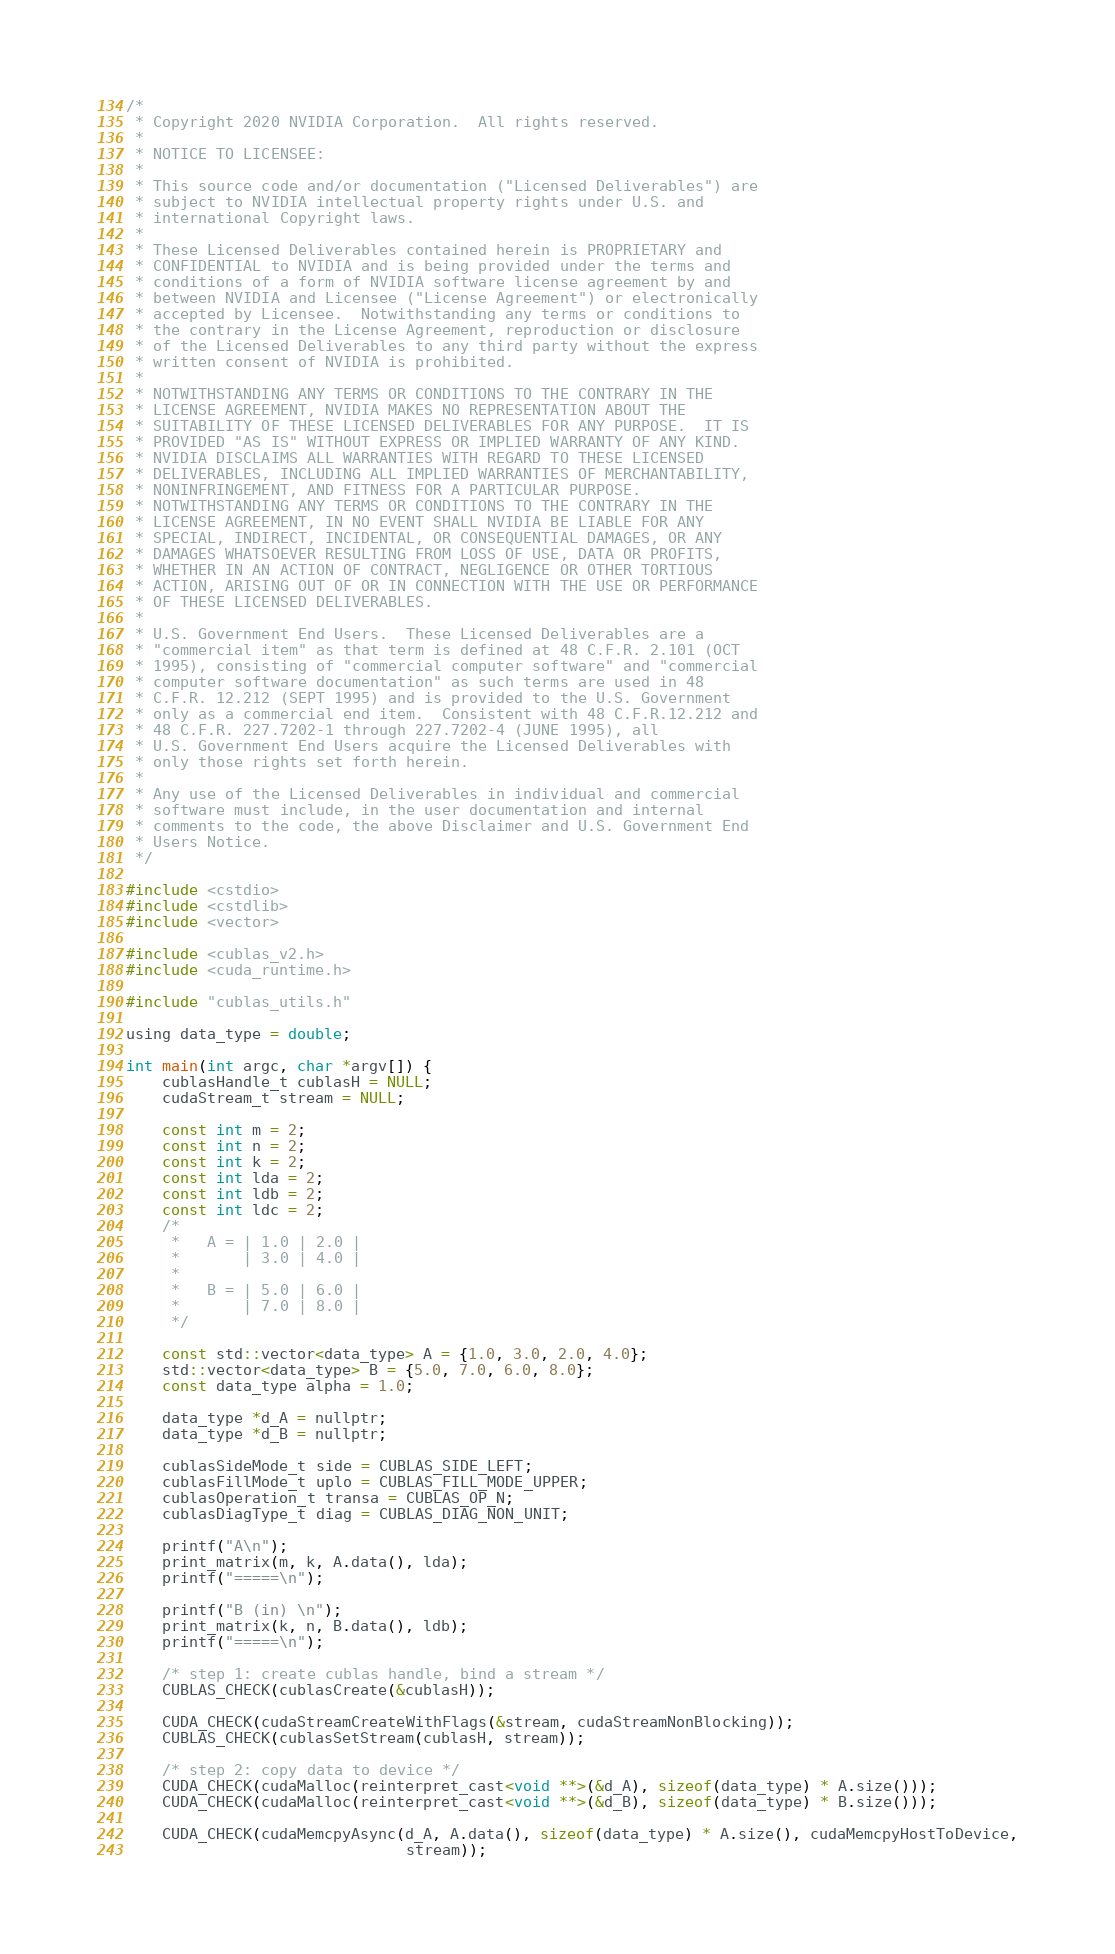<code> <loc_0><loc_0><loc_500><loc_500><_Cuda_>/*
 * Copyright 2020 NVIDIA Corporation.  All rights reserved.
 *
 * NOTICE TO LICENSEE:
 *
 * This source code and/or documentation ("Licensed Deliverables") are
 * subject to NVIDIA intellectual property rights under U.S. and
 * international Copyright laws.
 *
 * These Licensed Deliverables contained herein is PROPRIETARY and
 * CONFIDENTIAL to NVIDIA and is being provided under the terms and
 * conditions of a form of NVIDIA software license agreement by and
 * between NVIDIA and Licensee ("License Agreement") or electronically
 * accepted by Licensee.  Notwithstanding any terms or conditions to
 * the contrary in the License Agreement, reproduction or disclosure
 * of the Licensed Deliverables to any third party without the express
 * written consent of NVIDIA is prohibited.
 *
 * NOTWITHSTANDING ANY TERMS OR CONDITIONS TO THE CONTRARY IN THE
 * LICENSE AGREEMENT, NVIDIA MAKES NO REPRESENTATION ABOUT THE
 * SUITABILITY OF THESE LICENSED DELIVERABLES FOR ANY PURPOSE.  IT IS
 * PROVIDED "AS IS" WITHOUT EXPRESS OR IMPLIED WARRANTY OF ANY KIND.
 * NVIDIA DISCLAIMS ALL WARRANTIES WITH REGARD TO THESE LICENSED
 * DELIVERABLES, INCLUDING ALL IMPLIED WARRANTIES OF MERCHANTABILITY,
 * NONINFRINGEMENT, AND FITNESS FOR A PARTICULAR PURPOSE.
 * NOTWITHSTANDING ANY TERMS OR CONDITIONS TO THE CONTRARY IN THE
 * LICENSE AGREEMENT, IN NO EVENT SHALL NVIDIA BE LIABLE FOR ANY
 * SPECIAL, INDIRECT, INCIDENTAL, OR CONSEQUENTIAL DAMAGES, OR ANY
 * DAMAGES WHATSOEVER RESULTING FROM LOSS OF USE, DATA OR PROFITS,
 * WHETHER IN AN ACTION OF CONTRACT, NEGLIGENCE OR OTHER TORTIOUS
 * ACTION, ARISING OUT OF OR IN CONNECTION WITH THE USE OR PERFORMANCE
 * OF THESE LICENSED DELIVERABLES.
 *
 * U.S. Government End Users.  These Licensed Deliverables are a
 * "commercial item" as that term is defined at 48 C.F.R. 2.101 (OCT
 * 1995), consisting of "commercial computer software" and "commercial
 * computer software documentation" as such terms are used in 48
 * C.F.R. 12.212 (SEPT 1995) and is provided to the U.S. Government
 * only as a commercial end item.  Consistent with 48 C.F.R.12.212 and
 * 48 C.F.R. 227.7202-1 through 227.7202-4 (JUNE 1995), all
 * U.S. Government End Users acquire the Licensed Deliverables with
 * only those rights set forth herein.
 *
 * Any use of the Licensed Deliverables in individual and commercial
 * software must include, in the user documentation and internal
 * comments to the code, the above Disclaimer and U.S. Government End
 * Users Notice.
 */

#include <cstdio>
#include <cstdlib>
#include <vector>

#include <cublas_v2.h>
#include <cuda_runtime.h>

#include "cublas_utils.h"

using data_type = double;

int main(int argc, char *argv[]) {
    cublasHandle_t cublasH = NULL;
    cudaStream_t stream = NULL;

    const int m = 2;
    const int n = 2;
    const int k = 2;
    const int lda = 2;
    const int ldb = 2;
    const int ldc = 2;
    /*
     *   A = | 1.0 | 2.0 |
     *       | 3.0 | 4.0 |
     *
     *   B = | 5.0 | 6.0 |
     *       | 7.0 | 8.0 |
     */

    const std::vector<data_type> A = {1.0, 3.0, 2.0, 4.0};
    std::vector<data_type> B = {5.0, 7.0, 6.0, 8.0};
    const data_type alpha = 1.0;

    data_type *d_A = nullptr;
    data_type *d_B = nullptr;

    cublasSideMode_t side = CUBLAS_SIDE_LEFT;
    cublasFillMode_t uplo = CUBLAS_FILL_MODE_UPPER;
    cublasOperation_t transa = CUBLAS_OP_N;
    cublasDiagType_t diag = CUBLAS_DIAG_NON_UNIT;

    printf("A\n");
    print_matrix(m, k, A.data(), lda);
    printf("=====\n");

    printf("B (in) \n");
    print_matrix(k, n, B.data(), ldb);
    printf("=====\n");

    /* step 1: create cublas handle, bind a stream */
    CUBLAS_CHECK(cublasCreate(&cublasH));

    CUDA_CHECK(cudaStreamCreateWithFlags(&stream, cudaStreamNonBlocking));
    CUBLAS_CHECK(cublasSetStream(cublasH, stream));

    /* step 2: copy data to device */
    CUDA_CHECK(cudaMalloc(reinterpret_cast<void **>(&d_A), sizeof(data_type) * A.size()));
    CUDA_CHECK(cudaMalloc(reinterpret_cast<void **>(&d_B), sizeof(data_type) * B.size()));

    CUDA_CHECK(cudaMemcpyAsync(d_A, A.data(), sizeof(data_type) * A.size(), cudaMemcpyHostToDevice,
                               stream));</code> 